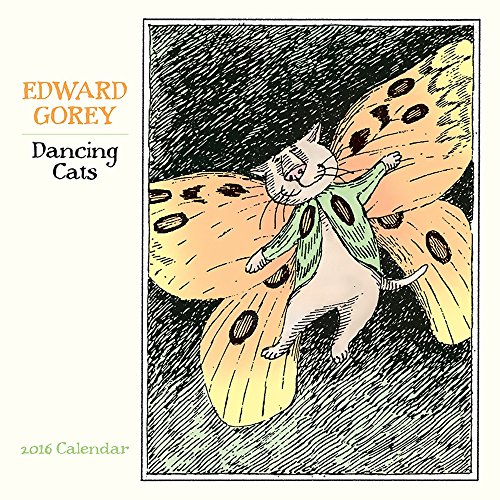Imagine there is a story behind this calendar page; what could be a brief narrative featuring this character? In a quaint village where cats walk upright, a feline named Sir Whiskers dons his finest butterfly costume for the grand Annual Moonlit Masquerade. As the celestial tunes play, he twirls and leaps with other costumed companions under a starlit sky, celebrating a mystical night where cats and fantasy converge. 